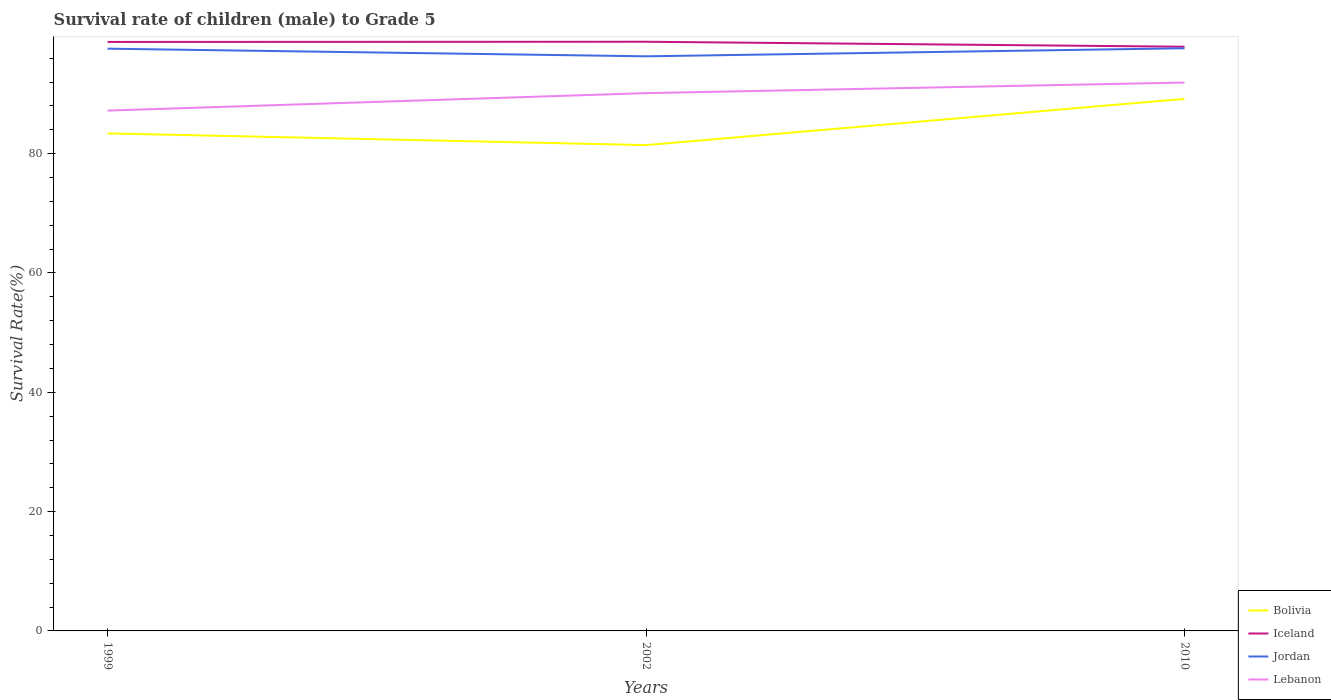Does the line corresponding to Jordan intersect with the line corresponding to Lebanon?
Offer a terse response. No. Across all years, what is the maximum survival rate of male children to grade 5 in Jordan?
Offer a terse response. 96.32. In which year was the survival rate of male children to grade 5 in Lebanon maximum?
Provide a succinct answer. 1999. What is the total survival rate of male children to grade 5 in Jordan in the graph?
Offer a terse response. -1.35. What is the difference between the highest and the second highest survival rate of male children to grade 5 in Jordan?
Keep it short and to the point. 1.35. What is the difference between the highest and the lowest survival rate of male children to grade 5 in Bolivia?
Your answer should be compact. 1. How many years are there in the graph?
Provide a short and direct response. 3. Are the values on the major ticks of Y-axis written in scientific E-notation?
Your answer should be compact. No. Does the graph contain any zero values?
Provide a succinct answer. No. Where does the legend appear in the graph?
Provide a short and direct response. Bottom right. How many legend labels are there?
Keep it short and to the point. 4. How are the legend labels stacked?
Your answer should be very brief. Vertical. What is the title of the graph?
Give a very brief answer. Survival rate of children (male) to Grade 5. Does "Puerto Rico" appear as one of the legend labels in the graph?
Your response must be concise. No. What is the label or title of the Y-axis?
Make the answer very short. Survival Rate(%). What is the Survival Rate(%) in Bolivia in 1999?
Make the answer very short. 83.4. What is the Survival Rate(%) in Iceland in 1999?
Provide a short and direct response. 98.73. What is the Survival Rate(%) of Jordan in 1999?
Your answer should be compact. 97.6. What is the Survival Rate(%) in Lebanon in 1999?
Your answer should be very brief. 87.22. What is the Survival Rate(%) in Bolivia in 2002?
Make the answer very short. 81.44. What is the Survival Rate(%) of Iceland in 2002?
Your answer should be compact. 98.76. What is the Survival Rate(%) in Jordan in 2002?
Your response must be concise. 96.32. What is the Survival Rate(%) in Lebanon in 2002?
Provide a succinct answer. 90.15. What is the Survival Rate(%) of Bolivia in 2010?
Your answer should be very brief. 89.19. What is the Survival Rate(%) of Iceland in 2010?
Your answer should be compact. 97.93. What is the Survival Rate(%) of Jordan in 2010?
Give a very brief answer. 97.67. What is the Survival Rate(%) of Lebanon in 2010?
Keep it short and to the point. 91.92. Across all years, what is the maximum Survival Rate(%) of Bolivia?
Give a very brief answer. 89.19. Across all years, what is the maximum Survival Rate(%) in Iceland?
Make the answer very short. 98.76. Across all years, what is the maximum Survival Rate(%) of Jordan?
Offer a very short reply. 97.67. Across all years, what is the maximum Survival Rate(%) of Lebanon?
Ensure brevity in your answer.  91.92. Across all years, what is the minimum Survival Rate(%) in Bolivia?
Your answer should be very brief. 81.44. Across all years, what is the minimum Survival Rate(%) of Iceland?
Your answer should be very brief. 97.93. Across all years, what is the minimum Survival Rate(%) in Jordan?
Your answer should be very brief. 96.32. Across all years, what is the minimum Survival Rate(%) of Lebanon?
Your response must be concise. 87.22. What is the total Survival Rate(%) in Bolivia in the graph?
Give a very brief answer. 254.03. What is the total Survival Rate(%) in Iceland in the graph?
Keep it short and to the point. 295.42. What is the total Survival Rate(%) of Jordan in the graph?
Keep it short and to the point. 291.59. What is the total Survival Rate(%) of Lebanon in the graph?
Provide a short and direct response. 269.29. What is the difference between the Survival Rate(%) of Bolivia in 1999 and that in 2002?
Keep it short and to the point. 1.97. What is the difference between the Survival Rate(%) of Iceland in 1999 and that in 2002?
Give a very brief answer. -0.03. What is the difference between the Survival Rate(%) in Jordan in 1999 and that in 2002?
Your answer should be very brief. 1.28. What is the difference between the Survival Rate(%) of Lebanon in 1999 and that in 2002?
Provide a short and direct response. -2.93. What is the difference between the Survival Rate(%) of Bolivia in 1999 and that in 2010?
Give a very brief answer. -5.79. What is the difference between the Survival Rate(%) in Iceland in 1999 and that in 2010?
Your answer should be very brief. 0.8. What is the difference between the Survival Rate(%) of Jordan in 1999 and that in 2010?
Your answer should be compact. -0.07. What is the difference between the Survival Rate(%) of Lebanon in 1999 and that in 2010?
Keep it short and to the point. -4.7. What is the difference between the Survival Rate(%) of Bolivia in 2002 and that in 2010?
Your answer should be very brief. -7.75. What is the difference between the Survival Rate(%) in Iceland in 2002 and that in 2010?
Keep it short and to the point. 0.83. What is the difference between the Survival Rate(%) of Jordan in 2002 and that in 2010?
Provide a succinct answer. -1.35. What is the difference between the Survival Rate(%) of Lebanon in 2002 and that in 2010?
Offer a very short reply. -1.77. What is the difference between the Survival Rate(%) of Bolivia in 1999 and the Survival Rate(%) of Iceland in 2002?
Offer a terse response. -15.36. What is the difference between the Survival Rate(%) of Bolivia in 1999 and the Survival Rate(%) of Jordan in 2002?
Provide a short and direct response. -12.92. What is the difference between the Survival Rate(%) in Bolivia in 1999 and the Survival Rate(%) in Lebanon in 2002?
Ensure brevity in your answer.  -6.75. What is the difference between the Survival Rate(%) in Iceland in 1999 and the Survival Rate(%) in Jordan in 2002?
Offer a very short reply. 2.41. What is the difference between the Survival Rate(%) of Iceland in 1999 and the Survival Rate(%) of Lebanon in 2002?
Your response must be concise. 8.58. What is the difference between the Survival Rate(%) of Jordan in 1999 and the Survival Rate(%) of Lebanon in 2002?
Offer a terse response. 7.45. What is the difference between the Survival Rate(%) in Bolivia in 1999 and the Survival Rate(%) in Iceland in 2010?
Provide a succinct answer. -14.53. What is the difference between the Survival Rate(%) in Bolivia in 1999 and the Survival Rate(%) in Jordan in 2010?
Make the answer very short. -14.27. What is the difference between the Survival Rate(%) in Bolivia in 1999 and the Survival Rate(%) in Lebanon in 2010?
Ensure brevity in your answer.  -8.52. What is the difference between the Survival Rate(%) of Iceland in 1999 and the Survival Rate(%) of Jordan in 2010?
Provide a succinct answer. 1.06. What is the difference between the Survival Rate(%) in Iceland in 1999 and the Survival Rate(%) in Lebanon in 2010?
Ensure brevity in your answer.  6.81. What is the difference between the Survival Rate(%) of Jordan in 1999 and the Survival Rate(%) of Lebanon in 2010?
Ensure brevity in your answer.  5.68. What is the difference between the Survival Rate(%) of Bolivia in 2002 and the Survival Rate(%) of Iceland in 2010?
Provide a short and direct response. -16.49. What is the difference between the Survival Rate(%) of Bolivia in 2002 and the Survival Rate(%) of Jordan in 2010?
Ensure brevity in your answer.  -16.24. What is the difference between the Survival Rate(%) of Bolivia in 2002 and the Survival Rate(%) of Lebanon in 2010?
Your answer should be compact. -10.48. What is the difference between the Survival Rate(%) of Iceland in 2002 and the Survival Rate(%) of Jordan in 2010?
Offer a very short reply. 1.09. What is the difference between the Survival Rate(%) in Iceland in 2002 and the Survival Rate(%) in Lebanon in 2010?
Keep it short and to the point. 6.84. What is the difference between the Survival Rate(%) in Jordan in 2002 and the Survival Rate(%) in Lebanon in 2010?
Offer a very short reply. 4.4. What is the average Survival Rate(%) in Bolivia per year?
Offer a terse response. 84.68. What is the average Survival Rate(%) in Iceland per year?
Offer a very short reply. 98.47. What is the average Survival Rate(%) of Jordan per year?
Make the answer very short. 97.2. What is the average Survival Rate(%) of Lebanon per year?
Offer a very short reply. 89.76. In the year 1999, what is the difference between the Survival Rate(%) in Bolivia and Survival Rate(%) in Iceland?
Give a very brief answer. -15.33. In the year 1999, what is the difference between the Survival Rate(%) in Bolivia and Survival Rate(%) in Jordan?
Keep it short and to the point. -14.2. In the year 1999, what is the difference between the Survival Rate(%) in Bolivia and Survival Rate(%) in Lebanon?
Keep it short and to the point. -3.82. In the year 1999, what is the difference between the Survival Rate(%) in Iceland and Survival Rate(%) in Jordan?
Your answer should be compact. 1.13. In the year 1999, what is the difference between the Survival Rate(%) of Iceland and Survival Rate(%) of Lebanon?
Provide a succinct answer. 11.51. In the year 1999, what is the difference between the Survival Rate(%) of Jordan and Survival Rate(%) of Lebanon?
Keep it short and to the point. 10.38. In the year 2002, what is the difference between the Survival Rate(%) of Bolivia and Survival Rate(%) of Iceland?
Provide a succinct answer. -17.33. In the year 2002, what is the difference between the Survival Rate(%) of Bolivia and Survival Rate(%) of Jordan?
Ensure brevity in your answer.  -14.88. In the year 2002, what is the difference between the Survival Rate(%) of Bolivia and Survival Rate(%) of Lebanon?
Your answer should be very brief. -8.71. In the year 2002, what is the difference between the Survival Rate(%) of Iceland and Survival Rate(%) of Jordan?
Your response must be concise. 2.44. In the year 2002, what is the difference between the Survival Rate(%) in Iceland and Survival Rate(%) in Lebanon?
Your answer should be compact. 8.61. In the year 2002, what is the difference between the Survival Rate(%) in Jordan and Survival Rate(%) in Lebanon?
Make the answer very short. 6.17. In the year 2010, what is the difference between the Survival Rate(%) in Bolivia and Survival Rate(%) in Iceland?
Keep it short and to the point. -8.74. In the year 2010, what is the difference between the Survival Rate(%) of Bolivia and Survival Rate(%) of Jordan?
Offer a very short reply. -8.48. In the year 2010, what is the difference between the Survival Rate(%) of Bolivia and Survival Rate(%) of Lebanon?
Your answer should be compact. -2.73. In the year 2010, what is the difference between the Survival Rate(%) of Iceland and Survival Rate(%) of Jordan?
Keep it short and to the point. 0.26. In the year 2010, what is the difference between the Survival Rate(%) in Iceland and Survival Rate(%) in Lebanon?
Ensure brevity in your answer.  6.01. In the year 2010, what is the difference between the Survival Rate(%) in Jordan and Survival Rate(%) in Lebanon?
Your answer should be compact. 5.75. What is the ratio of the Survival Rate(%) of Bolivia in 1999 to that in 2002?
Provide a succinct answer. 1.02. What is the ratio of the Survival Rate(%) of Iceland in 1999 to that in 2002?
Your answer should be compact. 1. What is the ratio of the Survival Rate(%) in Jordan in 1999 to that in 2002?
Provide a succinct answer. 1.01. What is the ratio of the Survival Rate(%) in Lebanon in 1999 to that in 2002?
Your answer should be compact. 0.97. What is the ratio of the Survival Rate(%) of Bolivia in 1999 to that in 2010?
Keep it short and to the point. 0.94. What is the ratio of the Survival Rate(%) of Iceland in 1999 to that in 2010?
Your response must be concise. 1.01. What is the ratio of the Survival Rate(%) in Lebanon in 1999 to that in 2010?
Offer a terse response. 0.95. What is the ratio of the Survival Rate(%) in Bolivia in 2002 to that in 2010?
Offer a terse response. 0.91. What is the ratio of the Survival Rate(%) in Iceland in 2002 to that in 2010?
Offer a very short reply. 1.01. What is the ratio of the Survival Rate(%) in Jordan in 2002 to that in 2010?
Offer a terse response. 0.99. What is the ratio of the Survival Rate(%) in Lebanon in 2002 to that in 2010?
Ensure brevity in your answer.  0.98. What is the difference between the highest and the second highest Survival Rate(%) of Bolivia?
Your response must be concise. 5.79. What is the difference between the highest and the second highest Survival Rate(%) in Iceland?
Your answer should be compact. 0.03. What is the difference between the highest and the second highest Survival Rate(%) in Jordan?
Provide a succinct answer. 0.07. What is the difference between the highest and the second highest Survival Rate(%) in Lebanon?
Offer a terse response. 1.77. What is the difference between the highest and the lowest Survival Rate(%) in Bolivia?
Your response must be concise. 7.75. What is the difference between the highest and the lowest Survival Rate(%) in Iceland?
Keep it short and to the point. 0.83. What is the difference between the highest and the lowest Survival Rate(%) of Jordan?
Ensure brevity in your answer.  1.35. What is the difference between the highest and the lowest Survival Rate(%) in Lebanon?
Provide a succinct answer. 4.7. 